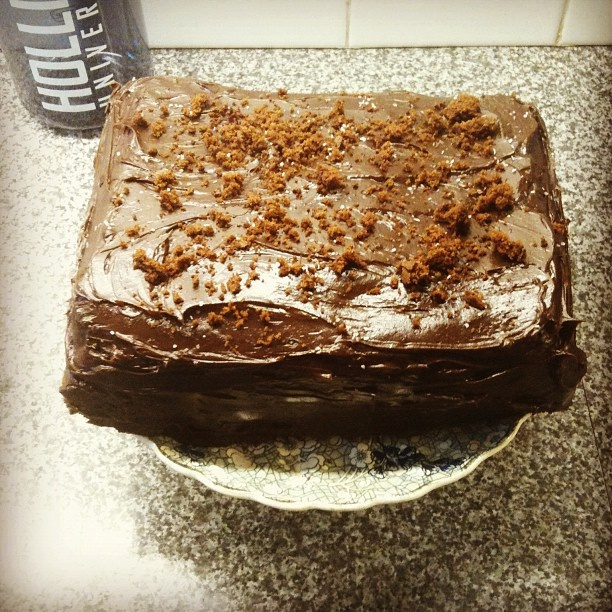Describe the objects in this image and their specific colors. I can see dining table in beige, black, maroon, and gray tones, cake in gray, black, maroon, brown, and tan tones, and bottle in gray, lightgray, and darkgray tones in this image. 